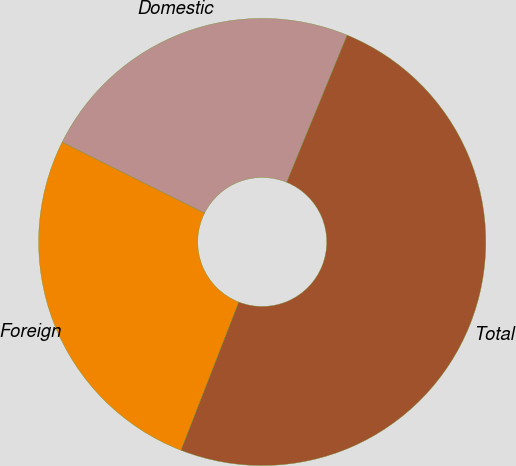<chart> <loc_0><loc_0><loc_500><loc_500><pie_chart><fcel>Domestic<fcel>Foreign<fcel>Total<nl><fcel>23.85%<fcel>26.44%<fcel>49.71%<nl></chart> 